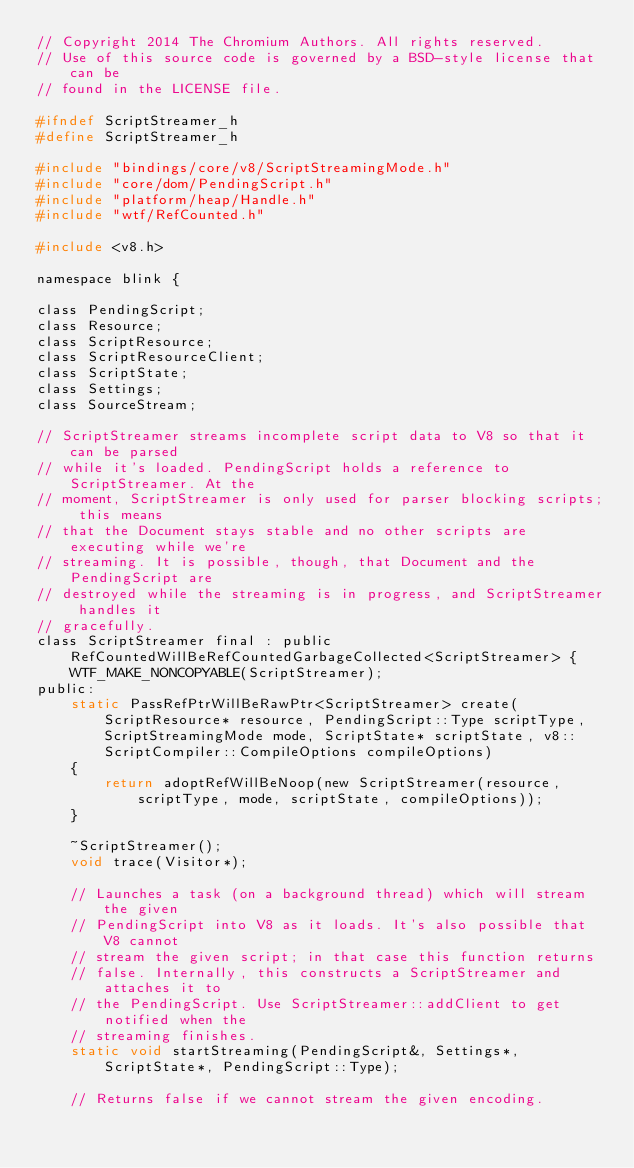Convert code to text. <code><loc_0><loc_0><loc_500><loc_500><_C_>// Copyright 2014 The Chromium Authors. All rights reserved.
// Use of this source code is governed by a BSD-style license that can be
// found in the LICENSE file.

#ifndef ScriptStreamer_h
#define ScriptStreamer_h

#include "bindings/core/v8/ScriptStreamingMode.h"
#include "core/dom/PendingScript.h"
#include "platform/heap/Handle.h"
#include "wtf/RefCounted.h"

#include <v8.h>

namespace blink {

class PendingScript;
class Resource;
class ScriptResource;
class ScriptResourceClient;
class ScriptState;
class Settings;
class SourceStream;

// ScriptStreamer streams incomplete script data to V8 so that it can be parsed
// while it's loaded. PendingScript holds a reference to ScriptStreamer. At the
// moment, ScriptStreamer is only used for parser blocking scripts; this means
// that the Document stays stable and no other scripts are executing while we're
// streaming. It is possible, though, that Document and the PendingScript are
// destroyed while the streaming is in progress, and ScriptStreamer handles it
// gracefully.
class ScriptStreamer final : public RefCountedWillBeRefCountedGarbageCollected<ScriptStreamer> {
    WTF_MAKE_NONCOPYABLE(ScriptStreamer);
public:
    static PassRefPtrWillBeRawPtr<ScriptStreamer> create(ScriptResource* resource, PendingScript::Type scriptType, ScriptStreamingMode mode, ScriptState* scriptState, v8::ScriptCompiler::CompileOptions compileOptions)
    {
        return adoptRefWillBeNoop(new ScriptStreamer(resource, scriptType, mode, scriptState, compileOptions));
    }

    ~ScriptStreamer();
    void trace(Visitor*);

    // Launches a task (on a background thread) which will stream the given
    // PendingScript into V8 as it loads. It's also possible that V8 cannot
    // stream the given script; in that case this function returns
    // false. Internally, this constructs a ScriptStreamer and attaches it to
    // the PendingScript. Use ScriptStreamer::addClient to get notified when the
    // streaming finishes.
    static void startStreaming(PendingScript&, Settings*, ScriptState*, PendingScript::Type);

    // Returns false if we cannot stream the given encoding.</code> 